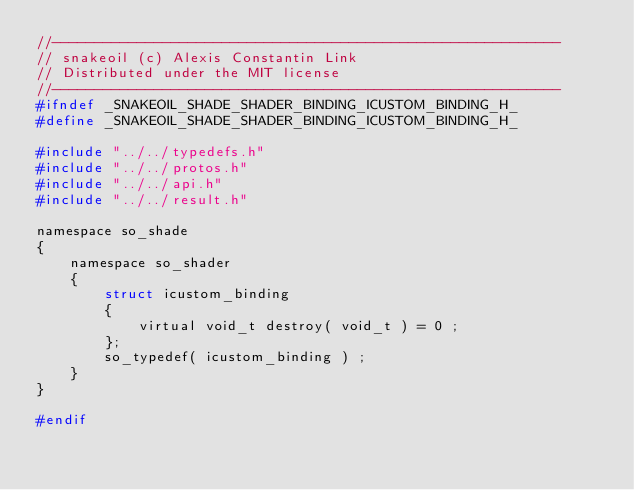Convert code to text. <code><loc_0><loc_0><loc_500><loc_500><_C_>//------------------------------------------------------------
// snakeoil (c) Alexis Constantin Link
// Distributed under the MIT license
//------------------------------------------------------------
#ifndef _SNAKEOIL_SHADE_SHADER_BINDING_ICUSTOM_BINDING_H_
#define _SNAKEOIL_SHADE_SHADER_BINDING_ICUSTOM_BINDING_H_

#include "../../typedefs.h"
#include "../../protos.h"
#include "../../api.h"
#include "../../result.h"

namespace so_shade
{
    namespace so_shader
    {
        struct icustom_binding
        {
            virtual void_t destroy( void_t ) = 0 ;
        };
        so_typedef( icustom_binding ) ;
    }
}

#endif
</code> 